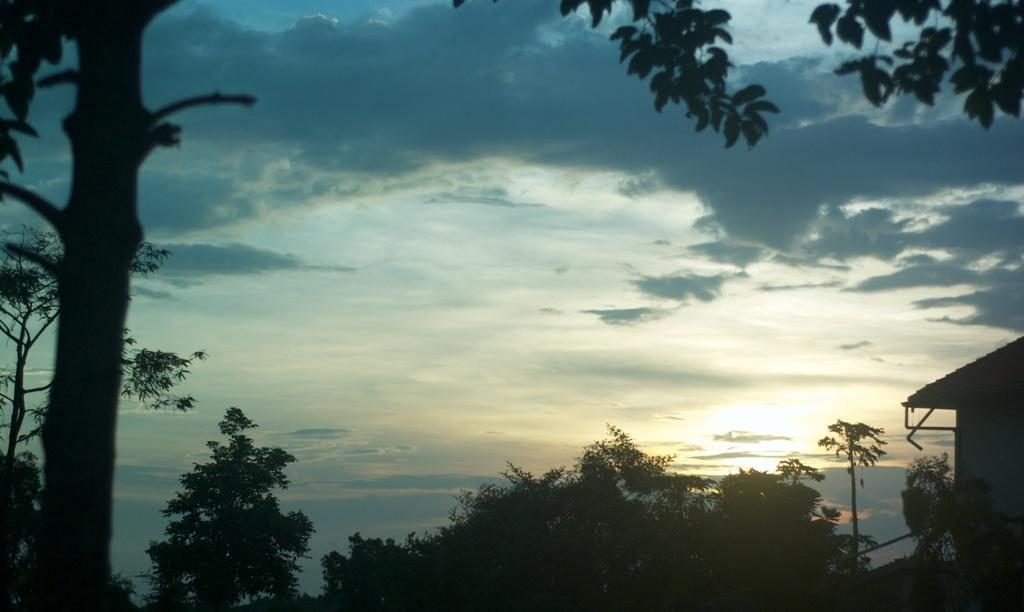What type of vegetation is at the bottom of the image? There are many trees at the bottom of the image. What structure is located on the right side of the image? There is a house on the right side of the image. What is visible at the top of the image? The sky is visible at the top of the image. What can be seen in the sky? Clouds are present in the sky. What type of cheese is hanging from the trees in the image? There is no cheese present in the image; it features trees and a house. What message is written on the note that is visible in the image? There is no note present in the image. 